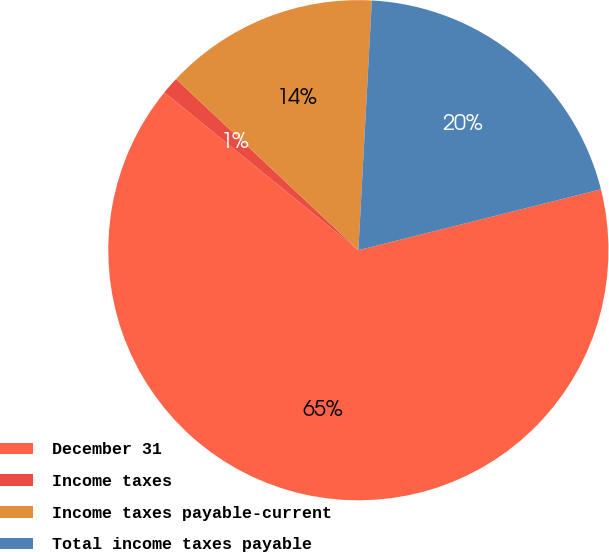Convert chart to OTSL. <chart><loc_0><loc_0><loc_500><loc_500><pie_chart><fcel>December 31<fcel>Income taxes<fcel>Income taxes payable-current<fcel>Total income taxes payable<nl><fcel>64.79%<fcel>1.13%<fcel>13.86%<fcel>20.23%<nl></chart> 